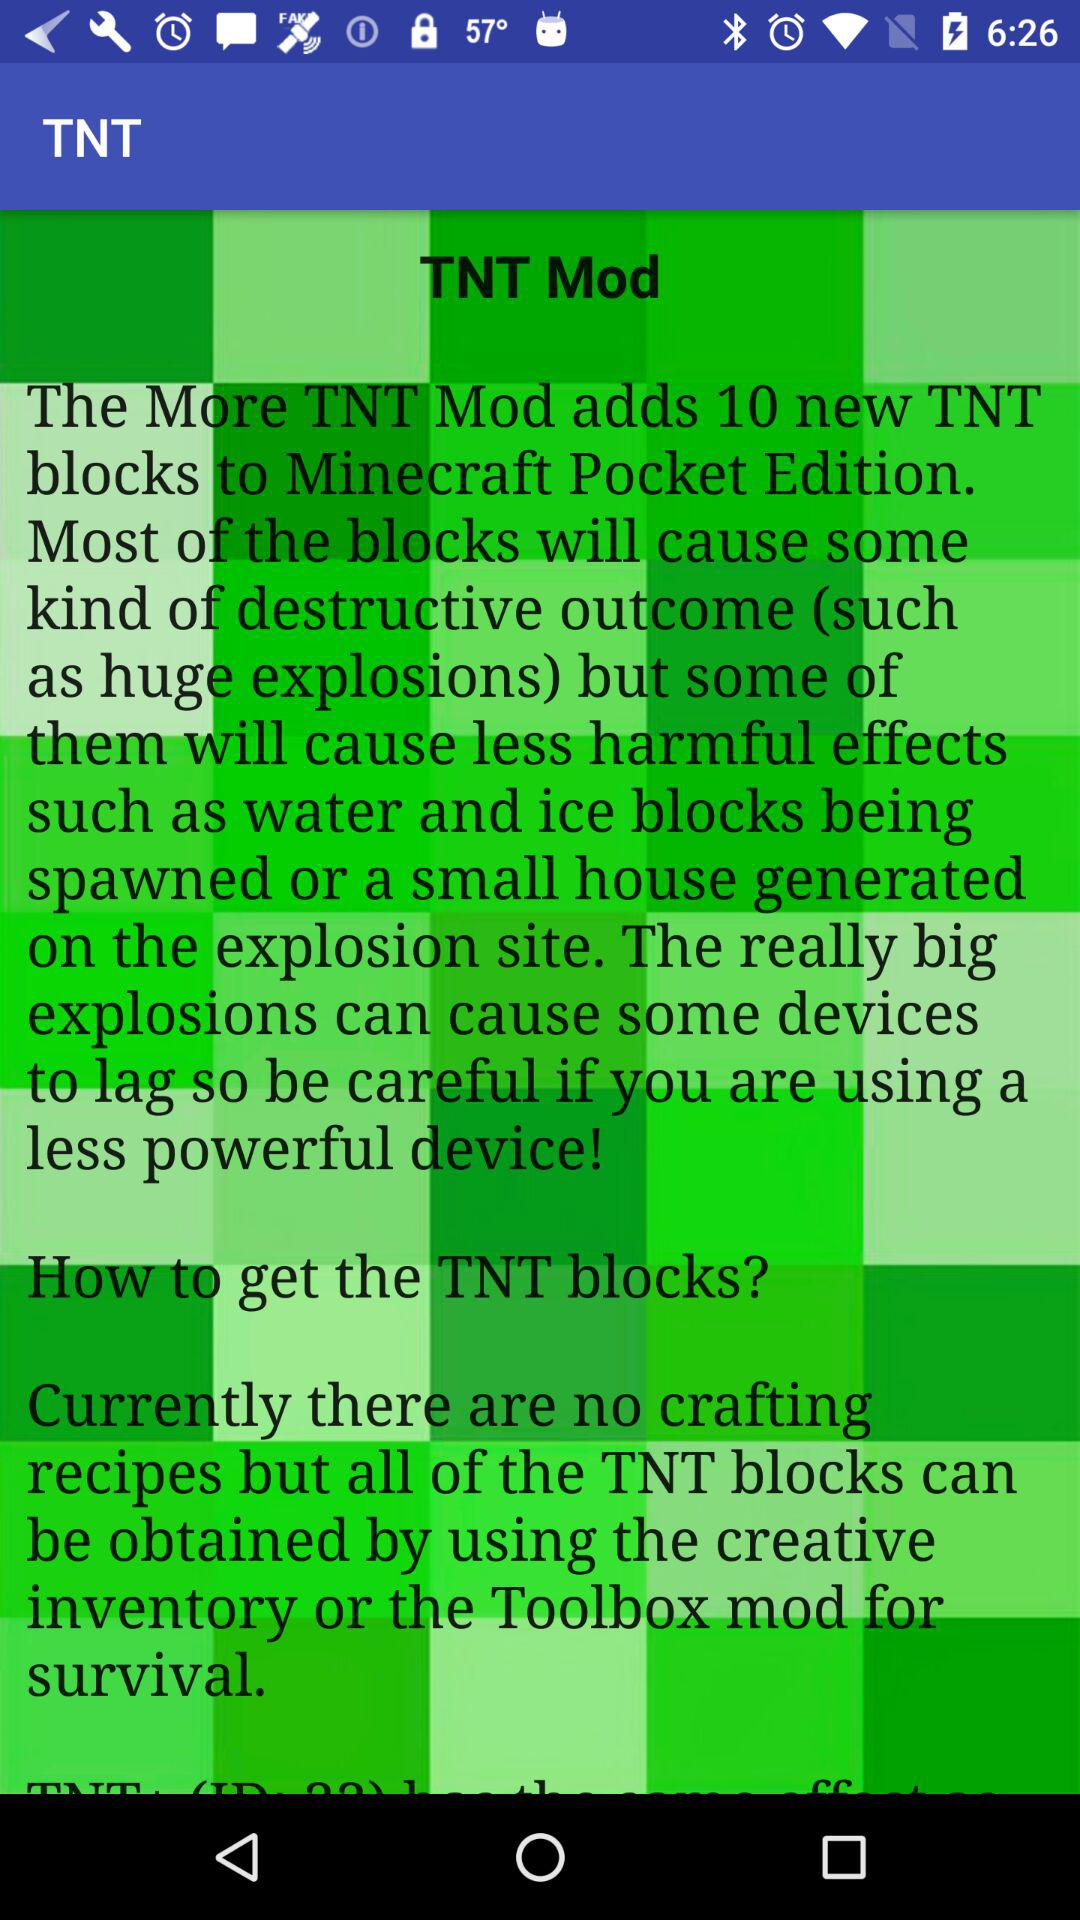How many types of TNT blocks are added by the mod?
Answer the question using a single word or phrase. 10 